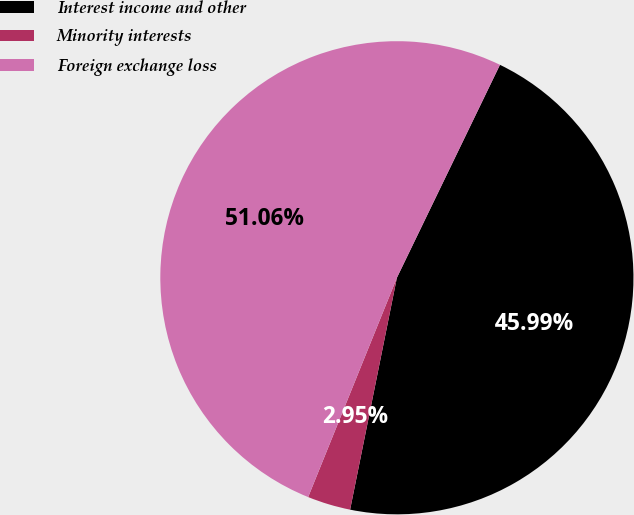Convert chart to OTSL. <chart><loc_0><loc_0><loc_500><loc_500><pie_chart><fcel>Interest income and other<fcel>Minority interests<fcel>Foreign exchange loss<nl><fcel>45.99%<fcel>2.95%<fcel>51.05%<nl></chart> 